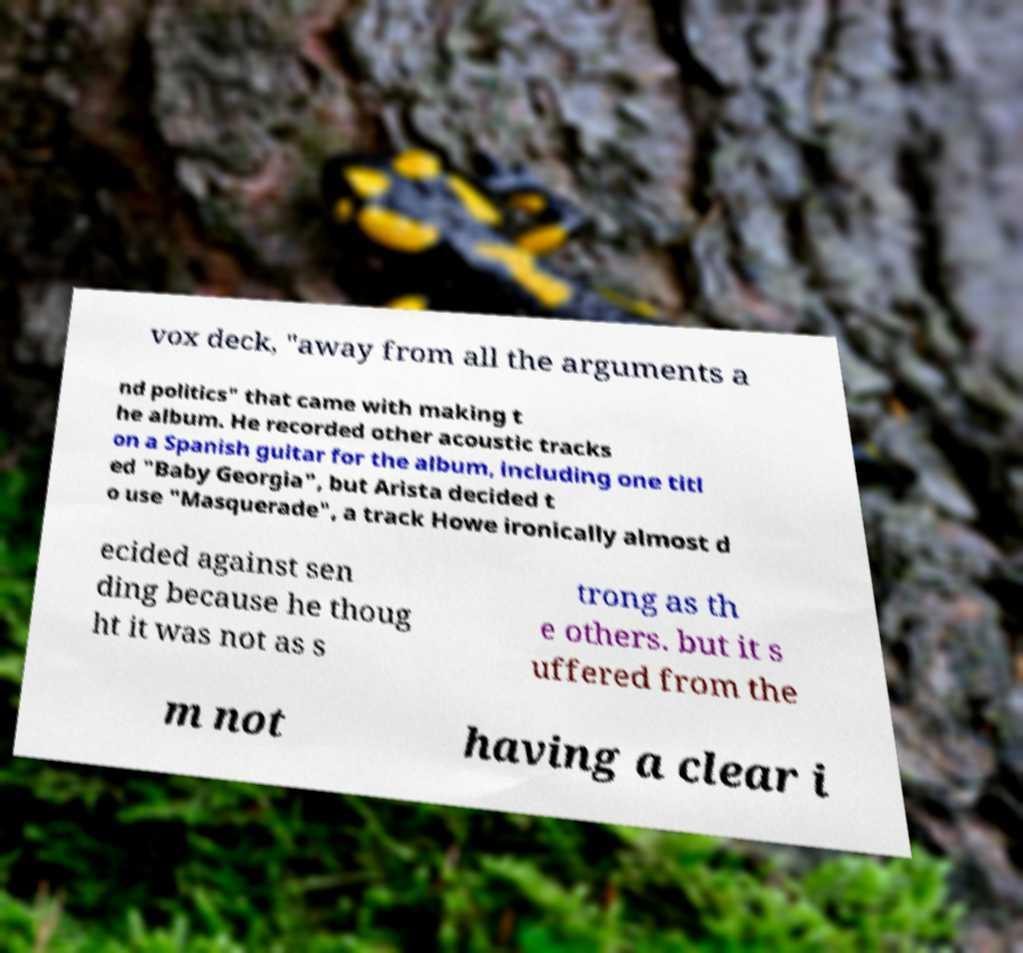Can you accurately transcribe the text from the provided image for me? vox deck, "away from all the arguments a nd politics" that came with making t he album. He recorded other acoustic tracks on a Spanish guitar for the album, including one titl ed "Baby Georgia", but Arista decided t o use "Masquerade", a track Howe ironically almost d ecided against sen ding because he thoug ht it was not as s trong as th e others. but it s uffered from the m not having a clear i 